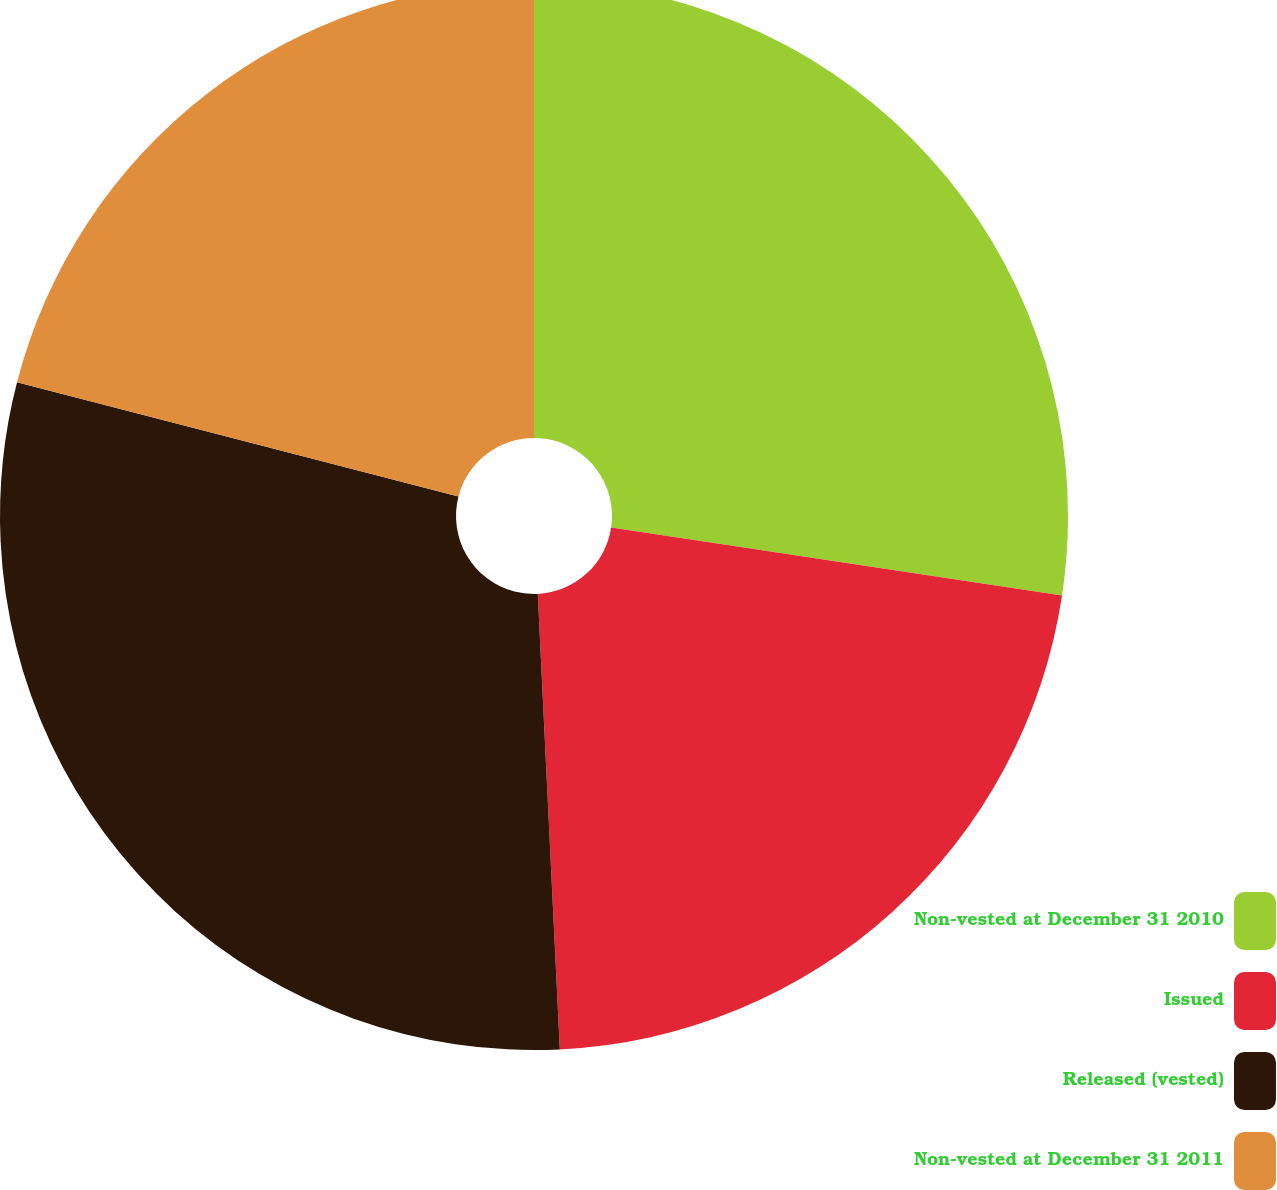<chart> <loc_0><loc_0><loc_500><loc_500><pie_chart><fcel>Non-vested at December 31 2010<fcel>Issued<fcel>Released (vested)<fcel>Non-vested at December 31 2011<nl><fcel>27.38%<fcel>21.85%<fcel>29.8%<fcel>20.97%<nl></chart> 